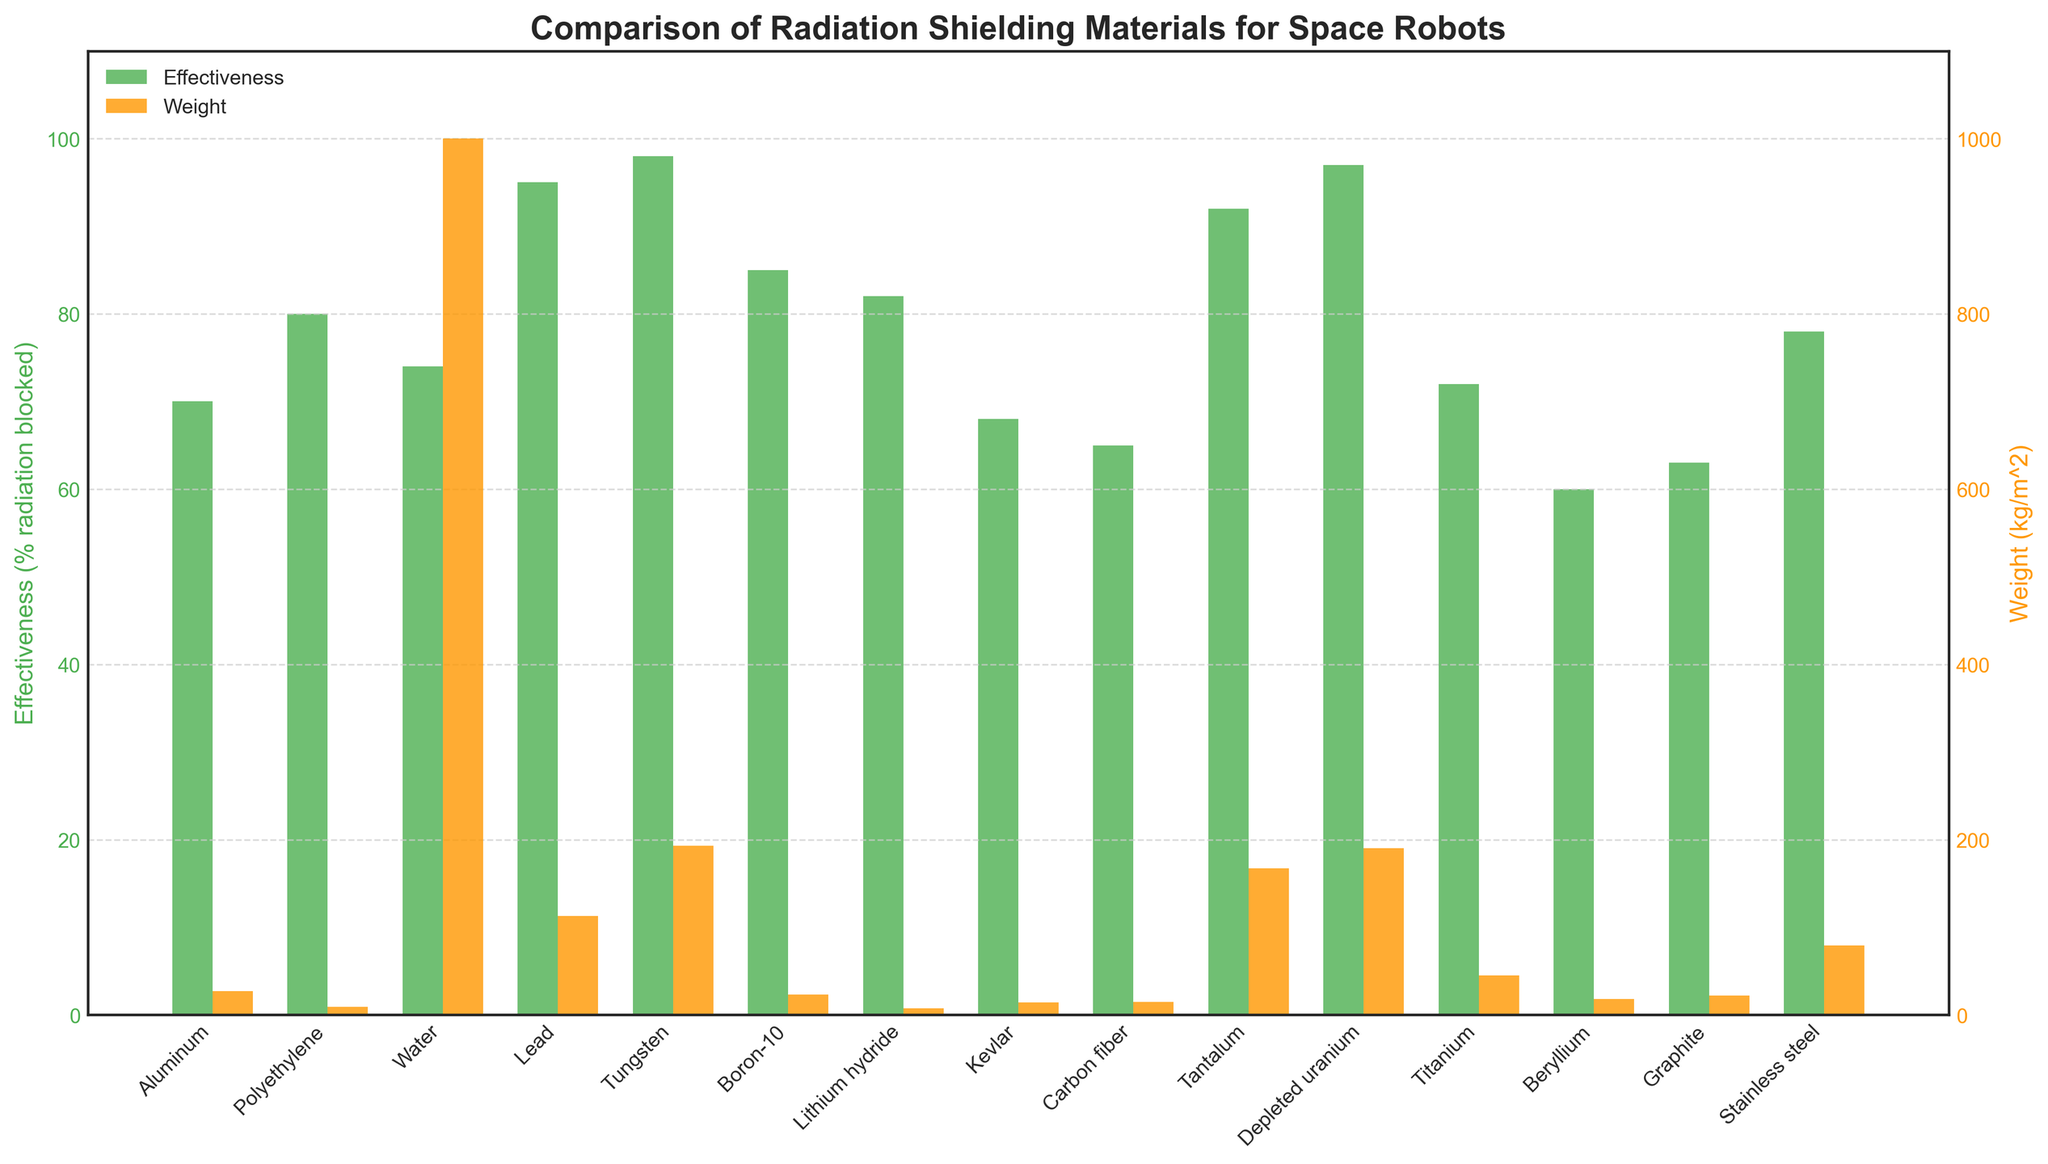Which material has the highest effectiveness and what is its weight? The tallest green bar represents effectiveness, which is for Tungsten at 98%. The corresponding orange bar indicates its weight, which is 193 kg/m^2.
Answer: Tungsten (98%, 193 kg/m^2) Which material has the lowest weight and what is its effectiveness? The shortest orange bar represents weight, which is for Lithium hydride at 7.6 kg/m^2. The corresponding green bar indicates its effectiveness, which is 82%.
Answer: Lithium hydride (82%, 7.6 kg/m^2) Among Aluminum and Kevlar, which material is more effective in blocking radiation and by how much? Compare the height of the green bars for Aluminum and Kevlar. Aluminum blocks 70% and Kevlar blocks 68%. The difference is 70% - 68% = 2%.
Answer: Aluminum by 2% Which material has a weight less than 50 kg/m^2 and the highest effectiveness? Examine the orange bars for weights less than 50 kg/m^2. Among them, Polyethylene (9.3), Boron-10 (23), Lithium hydride (7.6), Kevlar (14), Carbon fiber (15), and Graphite (22) qualify. The tallest green bar among these is for Polyethylene at 80%.
Answer: Polyethylene (80%) Calculate the average effectiveness of Aluminum, Polyethylene, and Titanium. Sum the effectiveness values of Aluminum (70), Polyethylene (80), and Titanium (72), then divide by 3. (70 + 80 + 72)/3 = 74.
Answer: 74 Which materials have a higher effectiveness than Stainless Steel? Identify green bars taller than Stainless Steel (78%). These materials are Polyethylene, Water, Lead, Tungsten, Boron-10, Lithium hydride, and Depleted uranium with 80%, 74%, 95%, 98%, 85%, 82%, and 97%, respectively.
Answer: Polyethylene, Water, Lead, Tungsten, Boron-10, Lithium hydride, Depleted uranium What's the difference in weight between Tantalum and Depleted Uranium? Tantalum’s weight is 167 kg/m^2 and Depleted Uranium’s weight is 190 kg/m^2. The difference is 190 - 167 = 23 kg/m^2.
Answer: 23 kg/m^2 How much more effective is Lead compared to Kevlar? Lead's effectiveness is 95% and Kevlar’s is 68%. The difference is 95% - 68% = 27%.
Answer: 27% What's the combined weight of materials with less than 80% effectiveness? Summing the weights of Aluminum (27), Kevlar (14), Carbon fiber (15), Titanium (45), Beryllium (18), and Graphite (22): 27 + 14 + 15 + 45 + 18 + 22 = 141 kg/m^2.
Answer: 141 kg/m^2 